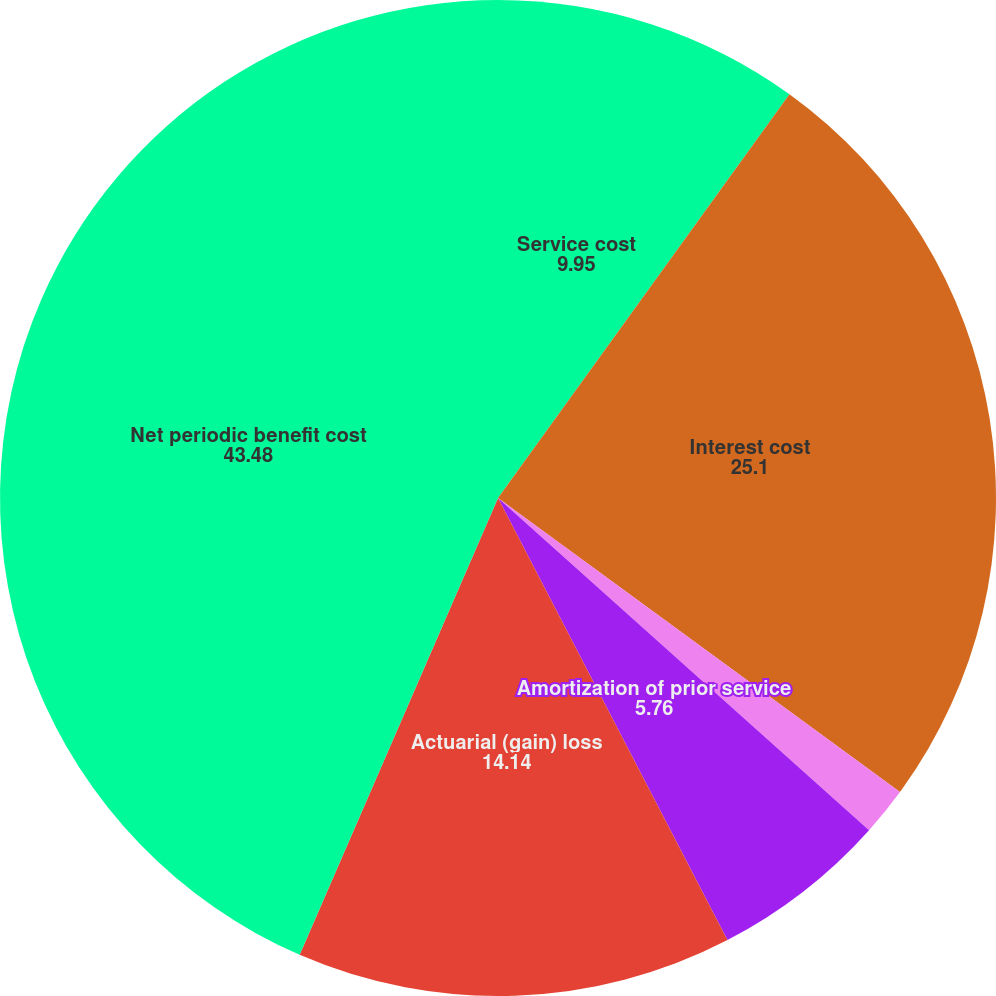Convert chart to OTSL. <chart><loc_0><loc_0><loc_500><loc_500><pie_chart><fcel>Service cost<fcel>Interest cost<fcel>Expected return on assets<fcel>Amortization of prior service<fcel>Actuarial (gain) loss<fcel>Net periodic benefit cost<nl><fcel>9.95%<fcel>25.1%<fcel>1.57%<fcel>5.76%<fcel>14.14%<fcel>43.48%<nl></chart> 